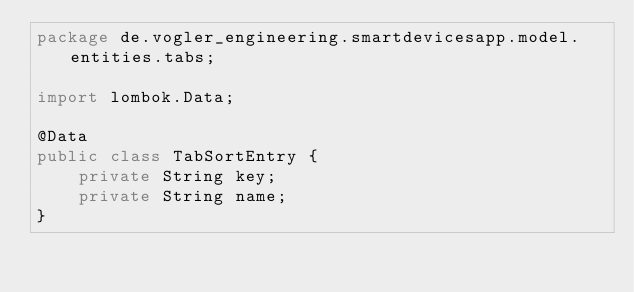Convert code to text. <code><loc_0><loc_0><loc_500><loc_500><_Java_>package de.vogler_engineering.smartdevicesapp.model.entities.tabs;

import lombok.Data;

@Data
public class TabSortEntry {
    private String key;
    private String name;
}
</code> 